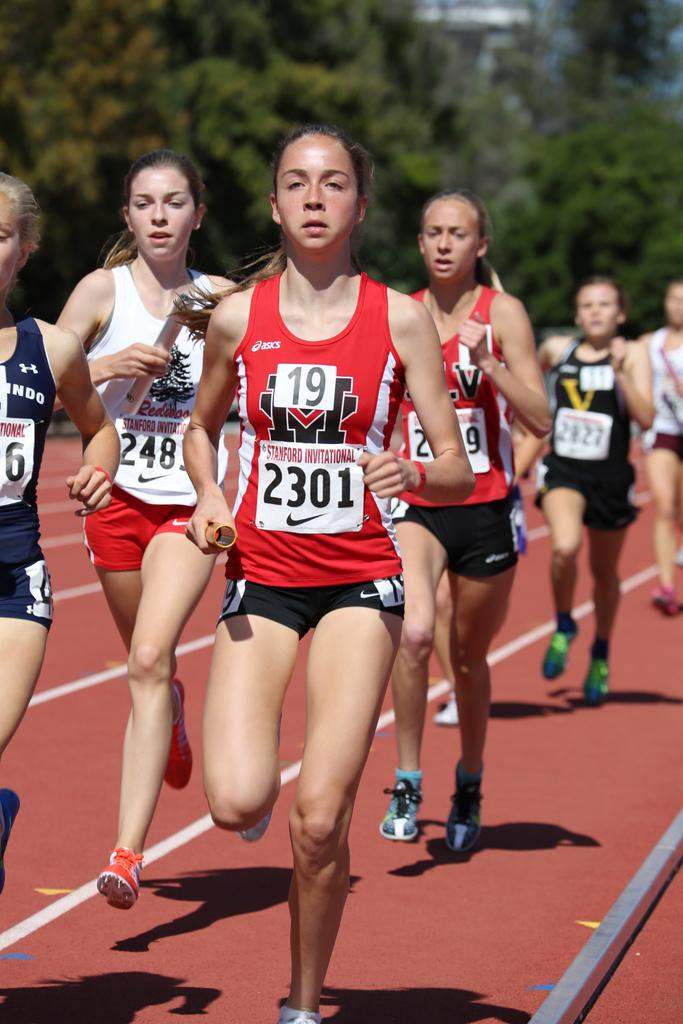<image>
Create a compact narrative representing the image presented. A group of girls running on a track with the girl in the front wearing a number 19 on her chest 